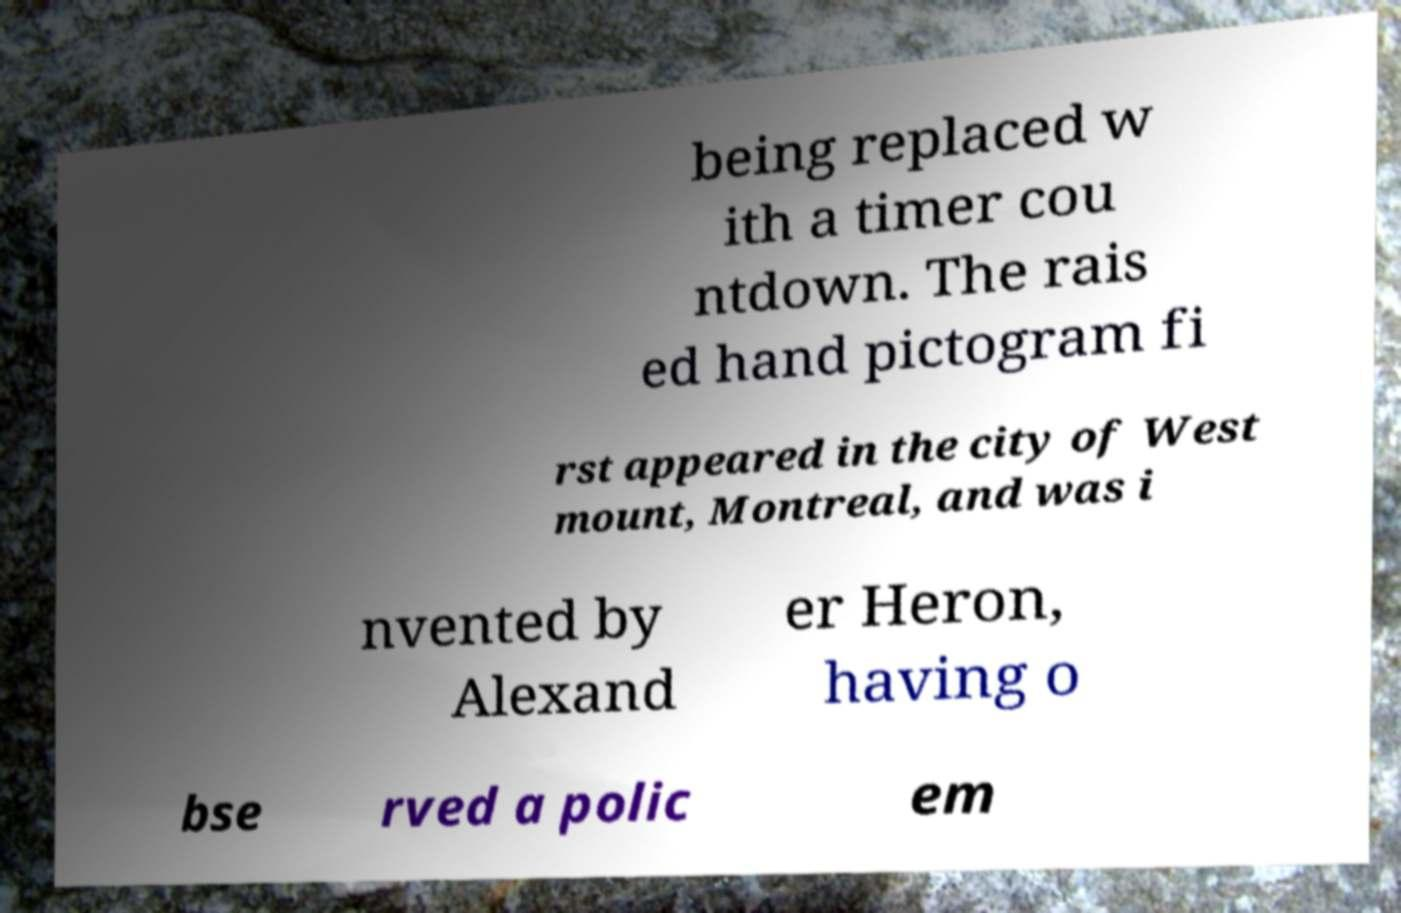I need the written content from this picture converted into text. Can you do that? being replaced w ith a timer cou ntdown. The rais ed hand pictogram fi rst appeared in the city of West mount, Montreal, and was i nvented by Alexand er Heron, having o bse rved a polic em 